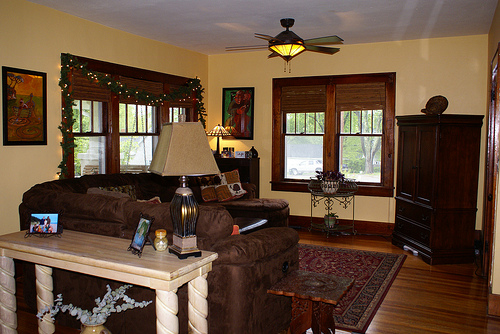What kind of ambiance does this room portray? The room exudes a warm and cozy ambiance, enriched by the earthy tones and soft illumination from decorative lights and table lamps. The combination of wooden furniture and lush decor creates an inviting and comfortable atmosphere. How would you feel spending an evening in this room? I imagine feeling quite relaxed and at ease. The soft lighting and comfortable seating would make for an ideal spot to unwind with a good book or chat with friends and family. Can you describe a possible scenario in this room during the winter season? Certainly! Picture this: It’s a chilly winter evening, and you're curled up on the soft, plush couch with a warm blanket draped over you. The wooden floors are slightly cold to the touch, so thick socks or slippers are a must. The nearby table holds a steaming mug of hot cocoa, topped with marshmallows, and a plate of freshly baked cookies. The room is softly lit with golden fairy lights wrapped around the window frame, casting a warm glow. Outside, snow gently falls, blanketing the world in white, while inside, the room remains a cozy oasis, filled with the soft sounds of crackling logs in the fireplace. 